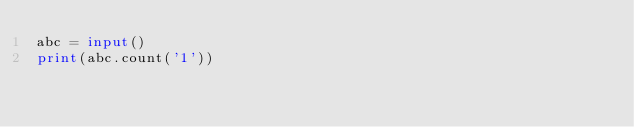Convert code to text. <code><loc_0><loc_0><loc_500><loc_500><_Python_>abc = input()
print(abc.count('1'))</code> 